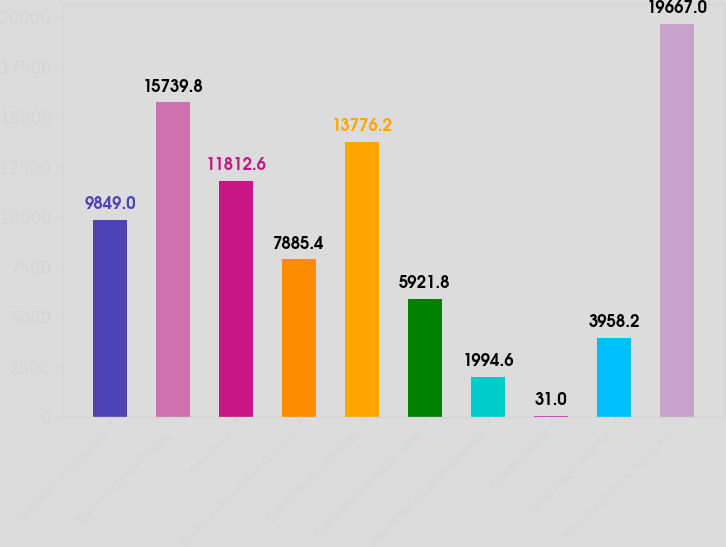<chart> <loc_0><loc_0><loc_500><loc_500><bar_chart><fcel>(in millions of US dollars)<fcel>Total shareholders' equity<fcel>Net income<fcel>Dividends declared on Common<fcel>Change in net unrealized<fcel>Cumulative translation net of<fcel>Income tax valuation allowance<fcel>Pension liability<fcel>Other movements net<fcel>Total shareholders' equity end<nl><fcel>9849<fcel>15739.8<fcel>11812.6<fcel>7885.4<fcel>13776.2<fcel>5921.8<fcel>1994.6<fcel>31<fcel>3958.2<fcel>19667<nl></chart> 